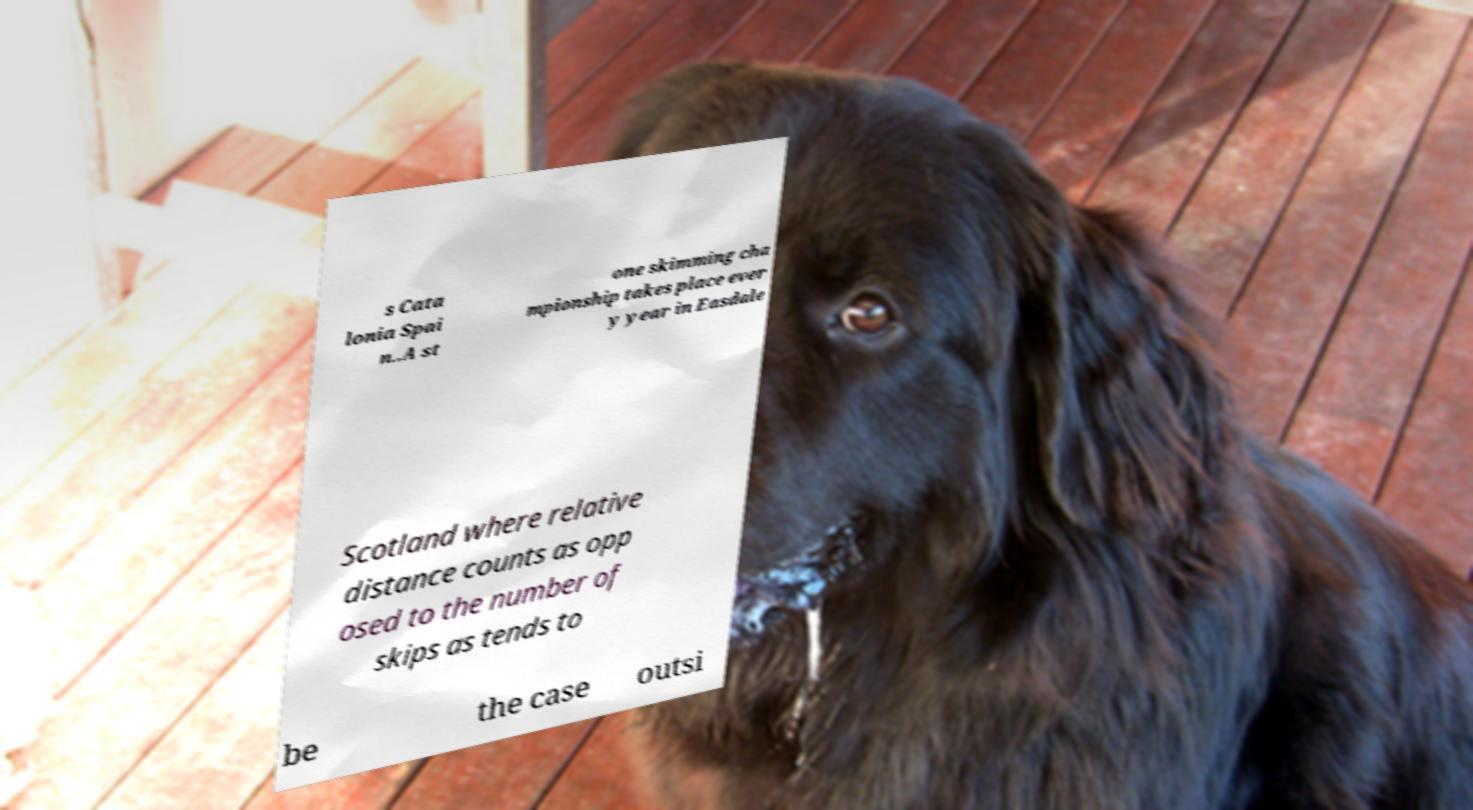Please read and relay the text visible in this image. What does it say? s Cata lonia Spai n..A st one skimming cha mpionship takes place ever y year in Easdale Scotland where relative distance counts as opp osed to the number of skips as tends to be the case outsi 